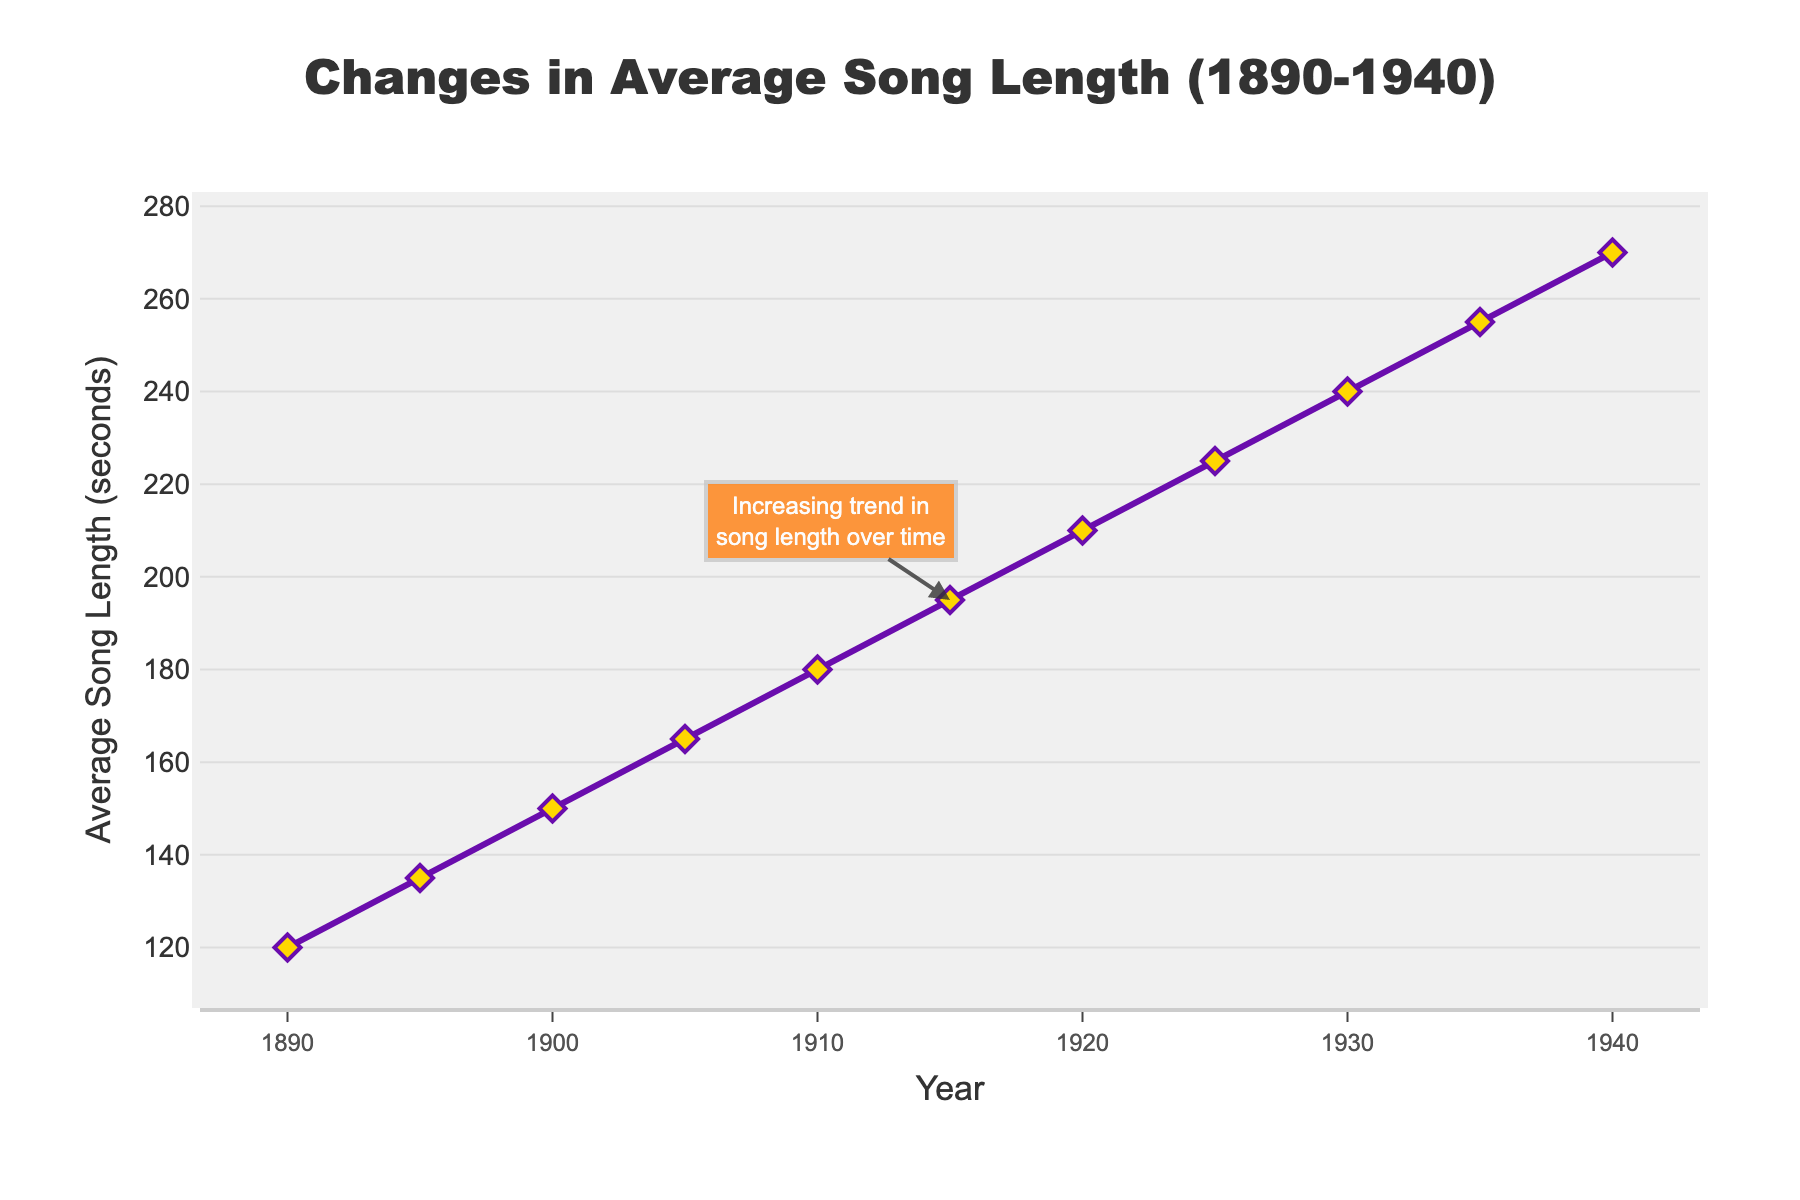Which year had the shortest average song length? By observing the beginning of the line chart, we see that the earliest data point is at the year 1890, with an average song length of 120 seconds.
Answer: 1890 Which year had the longest average song length? By observing the end of the line chart, we see that the latest data point is at the year 1940, with an average song length of 270 seconds.
Answer: 1940 By how many seconds did the average song length increase from 1890 to 1940? The average song length in 1890 is 120 seconds and in 1940 it is 270 seconds. The increase is calculated by subtracting the two values: 270 - 120 = 150 seconds.
Answer: 150 What is the average song length across all the years from 1890 to 1940? To find the average song length across all years, first sum the song lengths (120+135+150+165+180+195+210+225+240+255+270 = 2145 seconds) and then divide by the number of data points (11). The average is 2145 / 11 = 195 seconds.
Answer: 195 Was there any year when the average song length reached exactly 200 seconds? By examining the line chart and the data points for each year, we see that none of the years had an average song length of exactly 200 seconds.
Answer: No In which decade did the average song length increase the most? By analyzing the changes in average song length across each decade, we find the differences: 1890-1900: 30s, 1900-1910: 30s, 1910-1920: 30s, 1920-1930: 30s, and 1930-1940: 30s. Each decade shows an equal increase of 30 seconds.
Answer: All decades How much did the average song length increase from 1905 to 1935? The average song length in 1905 is 165 seconds and in 1935 it is 255 seconds. The increase is calculated by subtracting the two values: 255 - 165 = 90 seconds.
Answer: 90 What visual feature is used to emphasize the notable trend on the chart? There is a highlighted annotation placed at the year 1915, indicating the trend with text and an arrow pointing to the increasing song length. This feature emphasizes the continuous upward trend in average song length.
Answer: Annotation What was the average song length in 1925? By referring to the data point on the chart for the year 1925, we see that the average song length was 225 seconds.
Answer: 225 How did the average song length change between 1910 and 1920? By observing the specific data points for the years 1910 and 1920, we note an increase from 180 seconds to 210 seconds. The change is calculated by subtracting the values: 210 - 180 = 30 seconds.
Answer: Increased by 30 seconds 